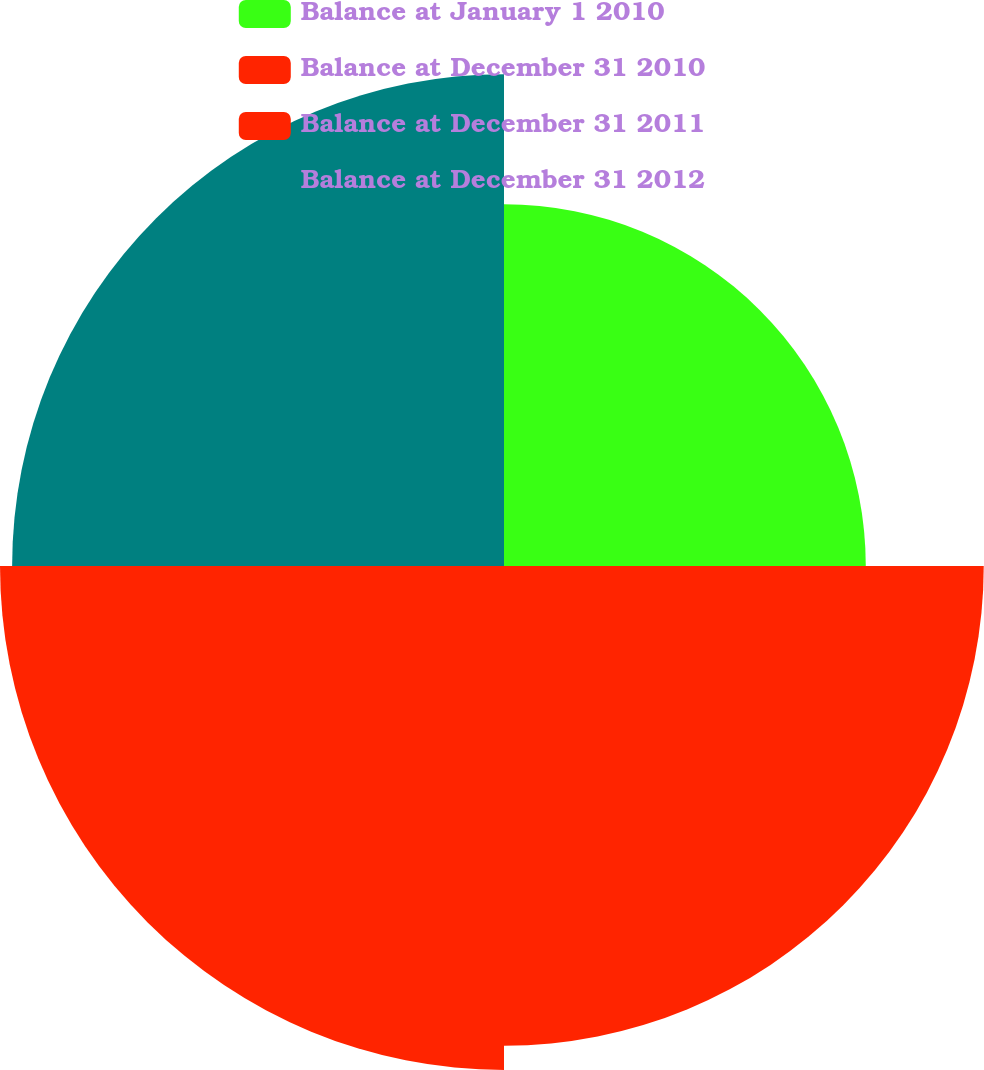Convert chart to OTSL. <chart><loc_0><loc_0><loc_500><loc_500><pie_chart><fcel>Balance at January 1 2010<fcel>Balance at December 31 2010<fcel>Balance at December 31 2011<fcel>Balance at December 31 2012<nl><fcel>19.69%<fcel>26.11%<fcel>27.43%<fcel>26.77%<nl></chart> 